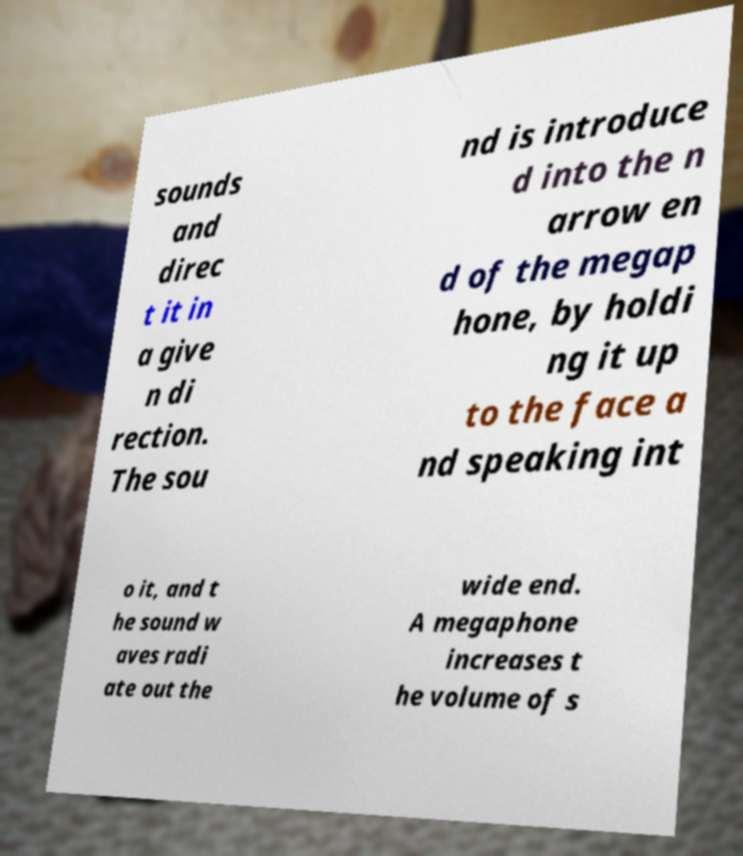For documentation purposes, I need the text within this image transcribed. Could you provide that? sounds and direc t it in a give n di rection. The sou nd is introduce d into the n arrow en d of the megap hone, by holdi ng it up to the face a nd speaking int o it, and t he sound w aves radi ate out the wide end. A megaphone increases t he volume of s 